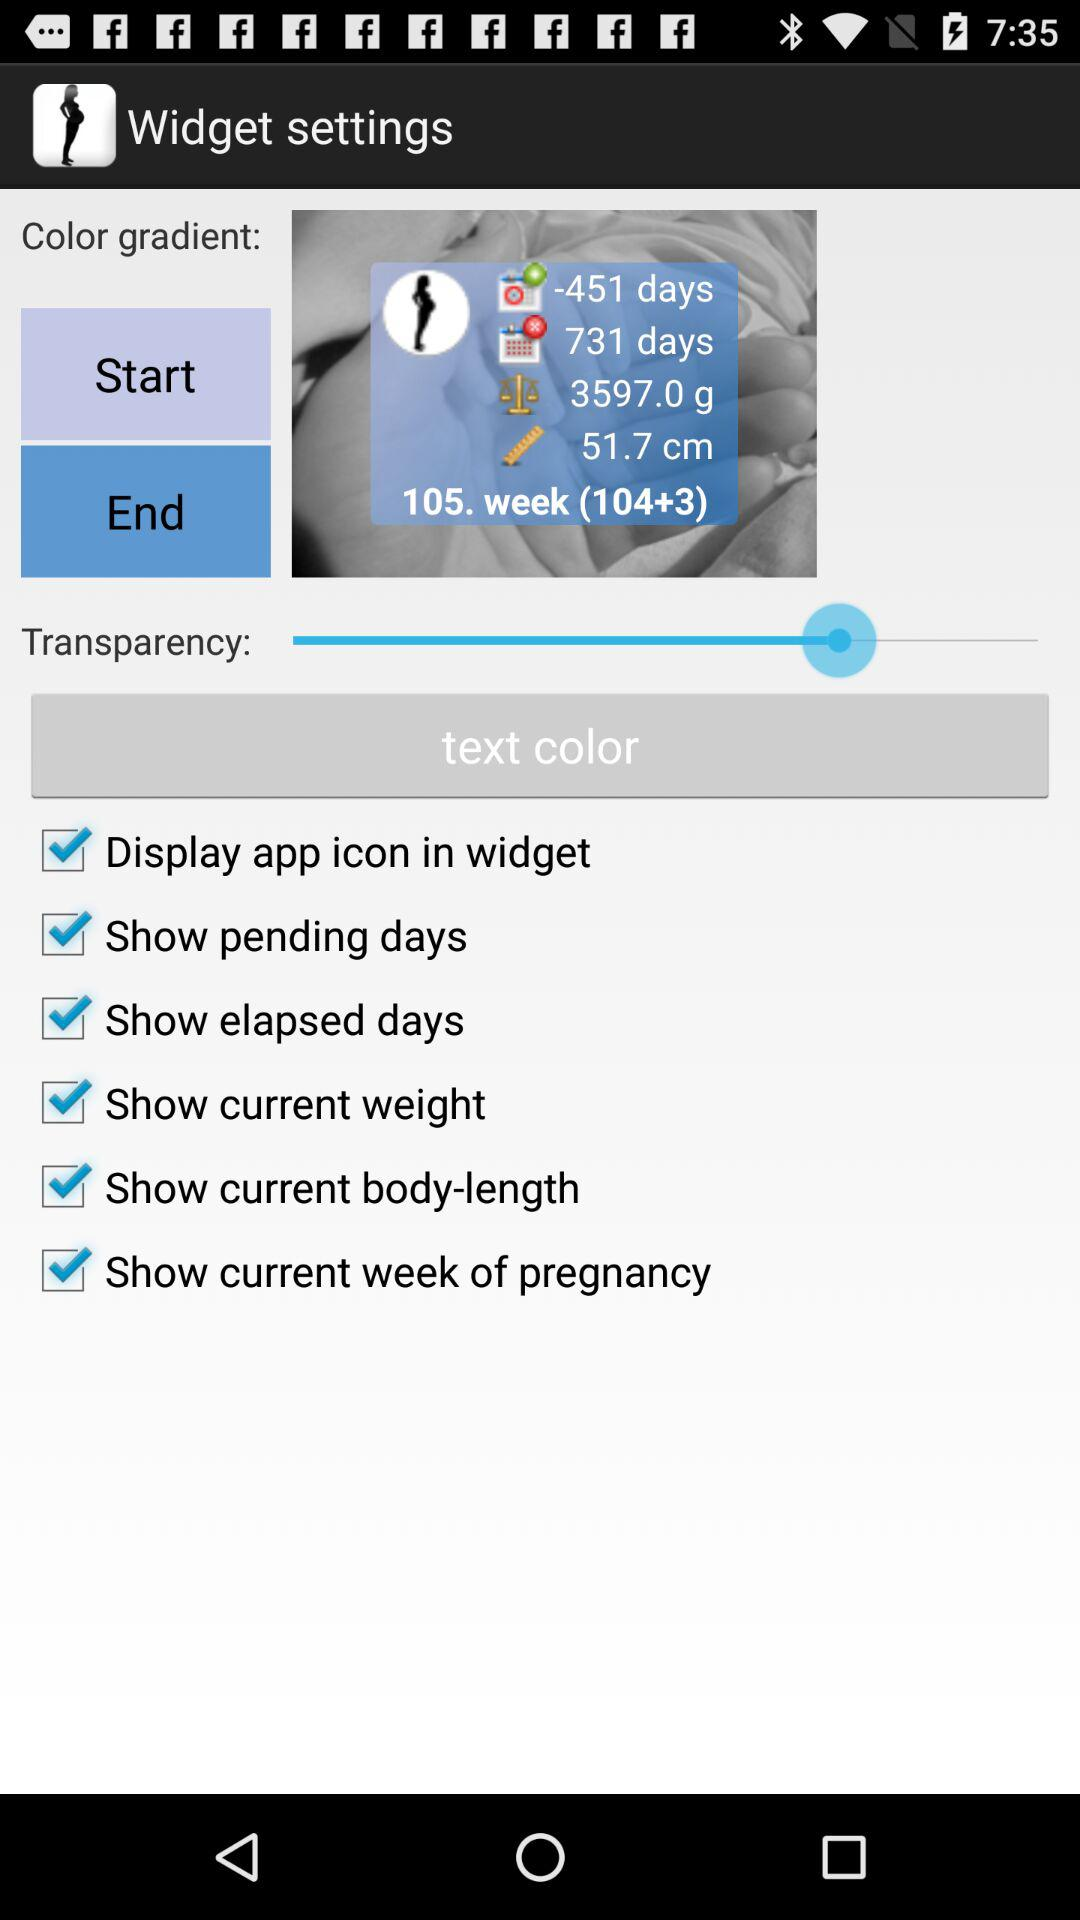How many weeks of pregnancy has the woman been through?
Answer the question using a single word or phrase. 105 